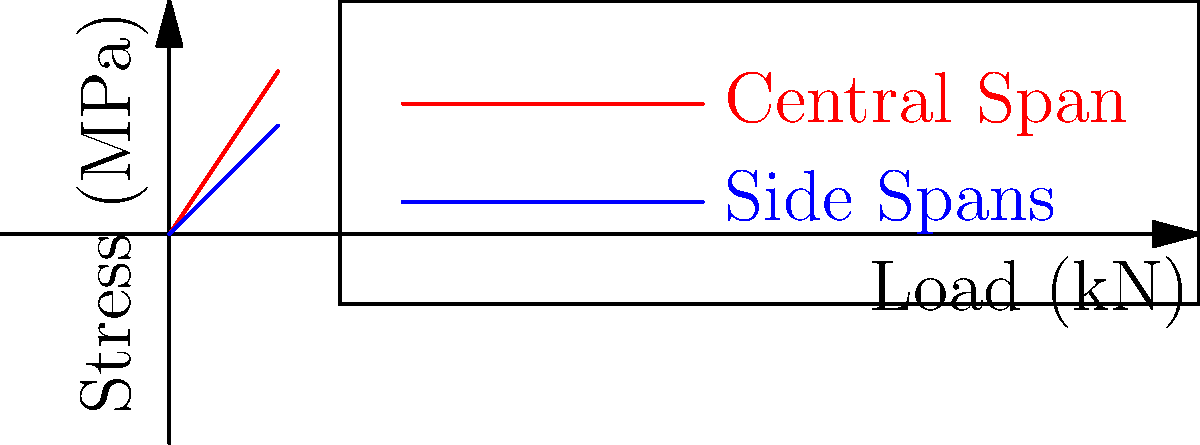As a financial advisor considering funding for a bridge project, you're presented with a stress analysis graph for different load conditions. The red line represents the central span, and the blue line represents the side spans. If the budget allows for a maximum stress of 55 MPa, what is the maximum allowable load that can be applied to the bridge structure? To determine the maximum allowable load, we need to analyze the graph and follow these steps:

1. Identify the critical component:
   The central span (red line) experiences higher stress levels than the side spans (blue line) for the same load.

2. Locate the stress limit on the graph:
   The maximum allowable stress is 55 MPa.

3. Find the corresponding load for the stress limit:
   Tracing a horizontal line from 55 MPa on the y-axis to the red line (central span).

4. Read the load value:
   The intersection point corresponds to approximately 37 kN on the x-axis.

5. Consider budget constraints:
   As a financial advisor resistant to experimental projects, it's prudent to choose a slightly lower value for safety and cost considerations.

Therefore, the maximum allowable load that can be applied to the bridge structure, considering both structural integrity and financial constraints, is approximately 35 kN.
Answer: 35 kN 